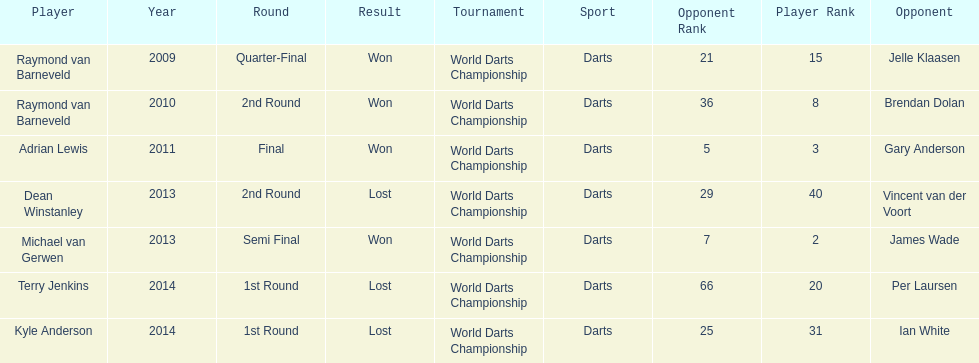Who won the first world darts championship? Raymond van Barneveld. 